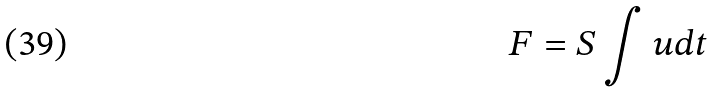Convert formula to latex. <formula><loc_0><loc_0><loc_500><loc_500>F = S \int u d t</formula> 